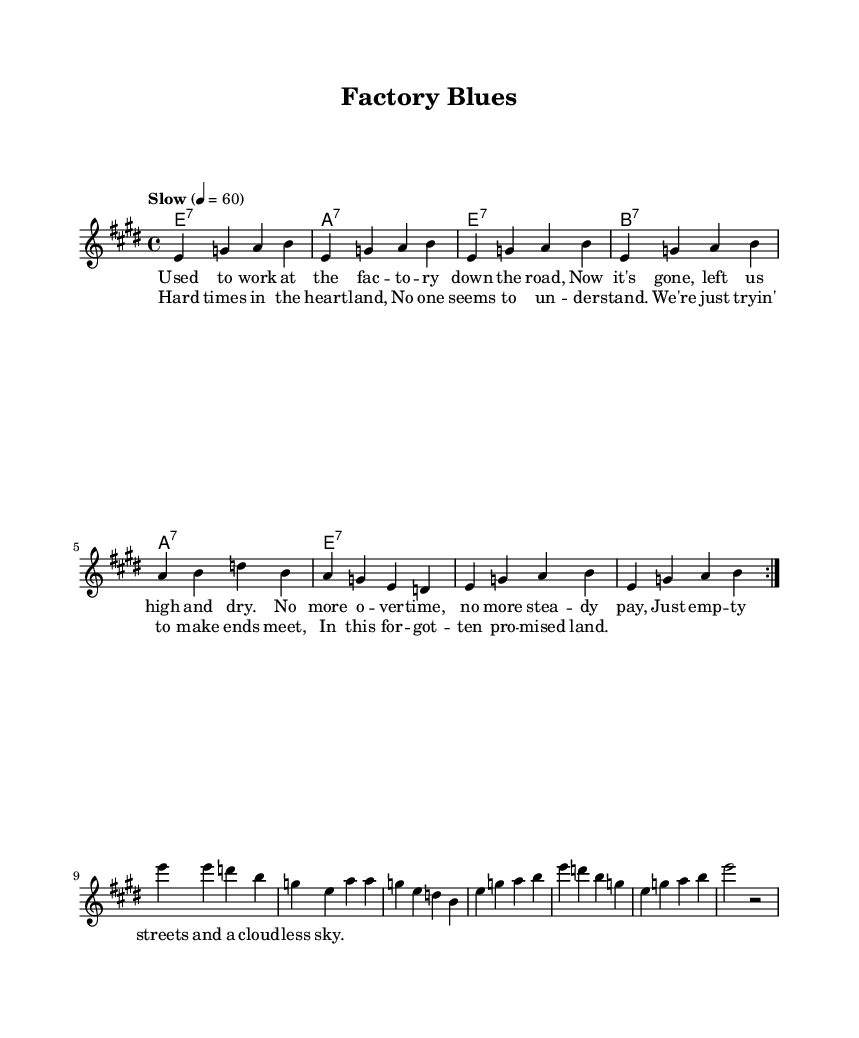What is the key signature of this music? The key signature is indicated at the beginning of the staff, showing three sharps, which corresponds to E major.
Answer: E major What is the time signature of this music? The time signature is shown at the beginning of the staff, indicated as 4/4, meaning there are four beats in each measure and the quarter note gets one beat.
Answer: 4/4 What is the tempo marking for this piece? The tempo marking is explicitly stated in the score as "Slow," indicating the intended pace of the music. This is further quantified with a metronome marking of 60 beats per minute.
Answer: Slow How many measures are there in the melody section? To find the number of measures, I can count the groupings in the melody section, which shows 8 repeating patterns marked by vertical lines. Each of these groups represents one measure.
Answer: 8 What type of musical form is used in the song? The structure consists of a repeating verse followed by a chorus, which aligns with common blues song structures, typically featuring a verse-chorus pattern.
Answer: Verse-Chorus What is the main theme expressed in the lyrics? The lyrics lament the loss of jobs and economic hardship, explicitly describing the struggles faced in rural America, highlighting feelings of abandonment and difficulty.
Answer: Economic hardship What type of harmony is described in this piece? The harmony indicated in the chord section utilizes seventh chords, which are characteristic of blues music, typically creating tension and a richer sound.
Answer: Seventh chords 